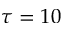<formula> <loc_0><loc_0><loc_500><loc_500>\tau = 1 0</formula> 